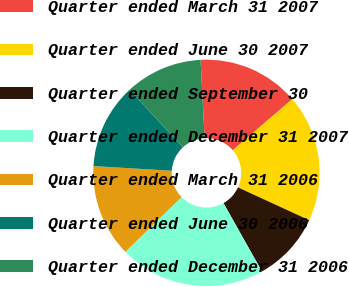Convert chart to OTSL. <chart><loc_0><loc_0><loc_500><loc_500><pie_chart><fcel>Quarter ended March 31 2007<fcel>Quarter ended June 30 2007<fcel>Quarter ended September 30<fcel>Quarter ended December 31 2007<fcel>Quarter ended March 31 2006<fcel>Quarter ended June 30 2006<fcel>Quarter ended December 31 2006<nl><fcel>14.54%<fcel>18.16%<fcel>9.97%<fcel>20.87%<fcel>13.25%<fcel>12.16%<fcel>11.06%<nl></chart> 